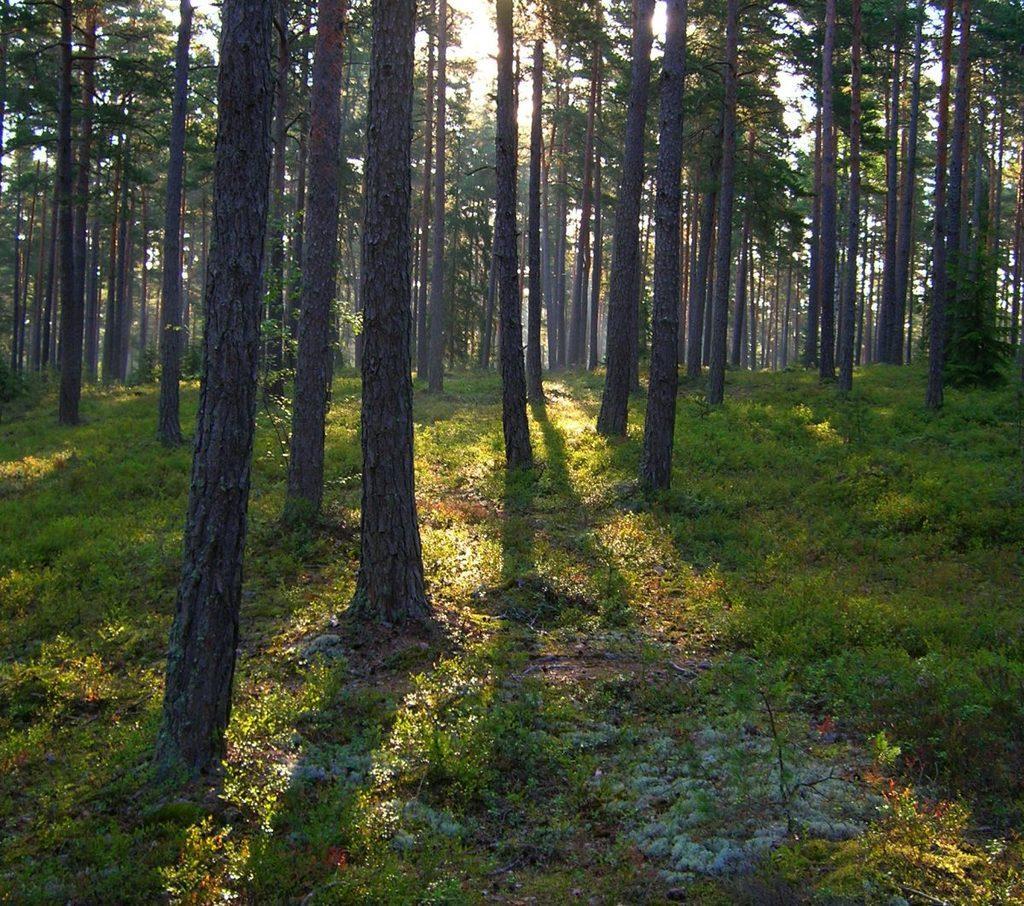Please provide a concise description of this image. In this picture we can see grass, few plants and trees. 